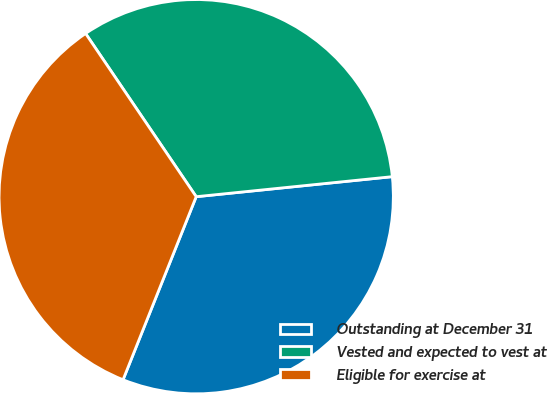<chart> <loc_0><loc_0><loc_500><loc_500><pie_chart><fcel>Outstanding at December 31<fcel>Vested and expected to vest at<fcel>Eligible for exercise at<nl><fcel>32.67%<fcel>32.86%<fcel>34.47%<nl></chart> 